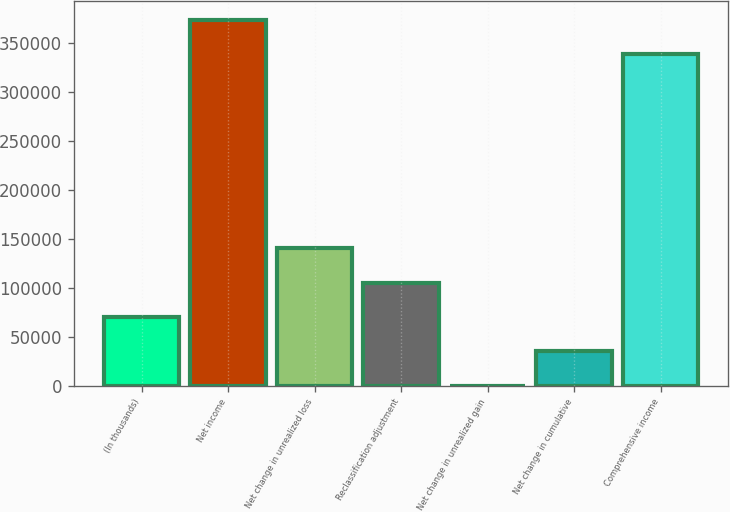<chart> <loc_0><loc_0><loc_500><loc_500><bar_chart><fcel>(In thousands)<fcel>Net income<fcel>Net change in unrealized loss<fcel>Reclassification adjustment<fcel>Net change in unrealized gain<fcel>Net change in cumulative<fcel>Comprehensive income<nl><fcel>70218.4<fcel>373521<fcel>140332<fcel>105275<fcel>105<fcel>35161.7<fcel>338464<nl></chart> 